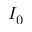Convert formula to latex. <formula><loc_0><loc_0><loc_500><loc_500>I _ { 0 }</formula> 